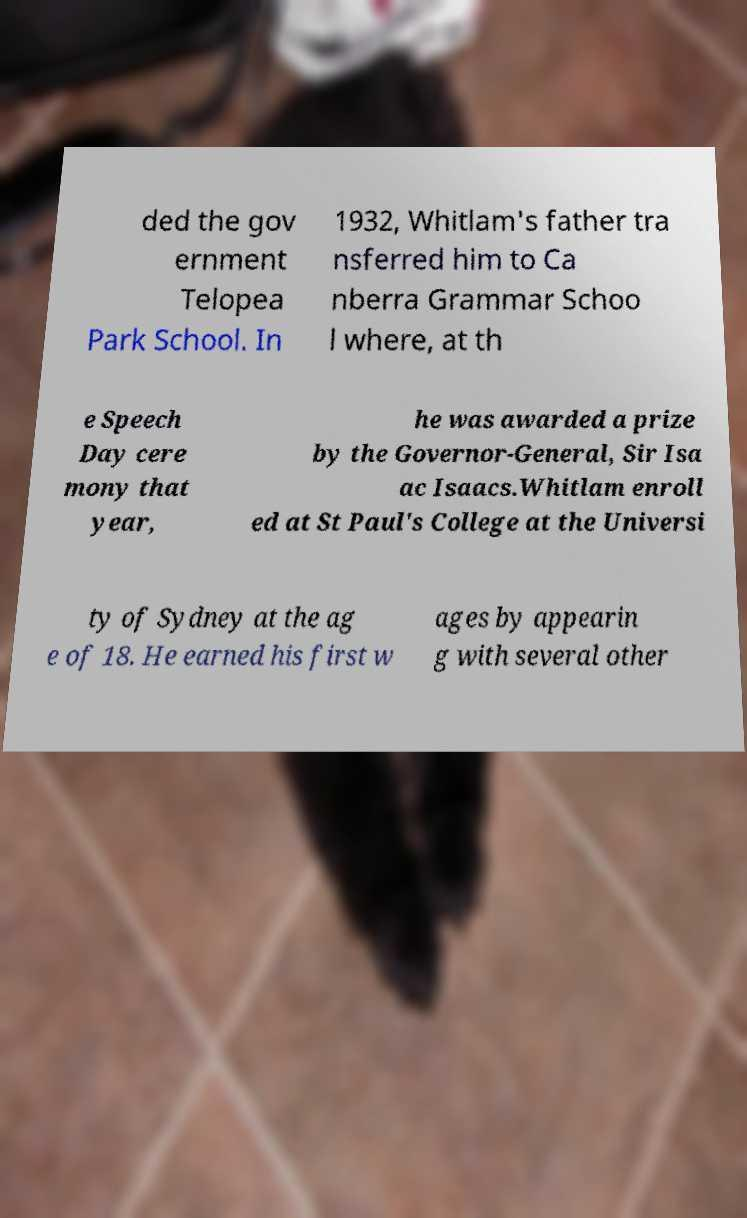Could you extract and type out the text from this image? ded the gov ernment Telopea Park School. In 1932, Whitlam's father tra nsferred him to Ca nberra Grammar Schoo l where, at th e Speech Day cere mony that year, he was awarded a prize by the Governor-General, Sir Isa ac Isaacs.Whitlam enroll ed at St Paul's College at the Universi ty of Sydney at the ag e of 18. He earned his first w ages by appearin g with several other 